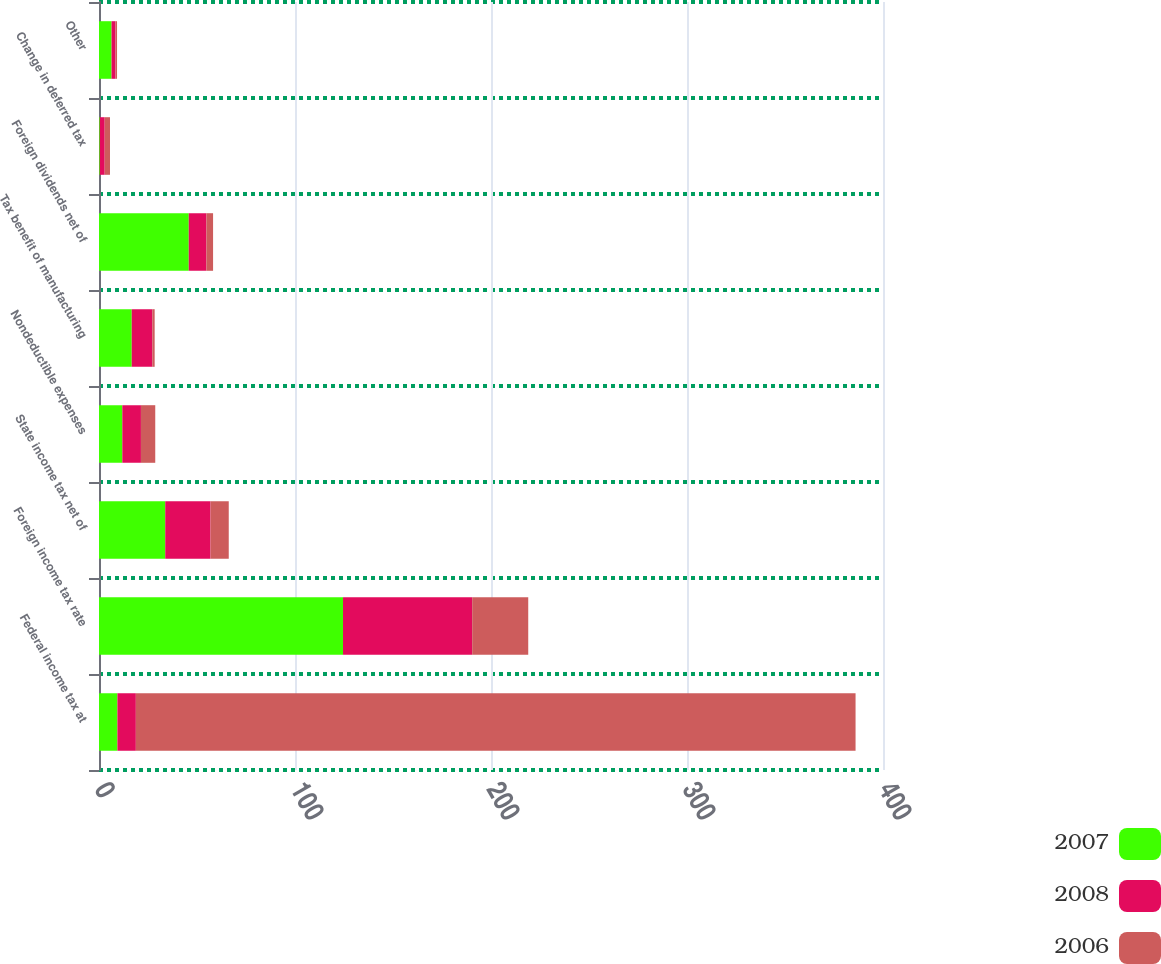<chart> <loc_0><loc_0><loc_500><loc_500><stacked_bar_chart><ecel><fcel>Federal income tax at<fcel>Foreign income tax rate<fcel>State income tax net of<fcel>Nondeductible expenses<fcel>Tax benefit of manufacturing<fcel>Foreign dividends net of<fcel>Change in deferred tax<fcel>Other<nl><fcel>2007<fcel>9.4<fcel>124.5<fcel>33.8<fcel>11.9<fcel>16.7<fcel>45.8<fcel>0.4<fcel>6.4<nl><fcel>2008<fcel>9.4<fcel>65.9<fcel>23.1<fcel>9.5<fcel>10.5<fcel>9<fcel>2.5<fcel>2<nl><fcel>2006<fcel>367.2<fcel>28.6<fcel>9.3<fcel>7.3<fcel>1.2<fcel>3.4<fcel>2.7<fcel>0.8<nl></chart> 